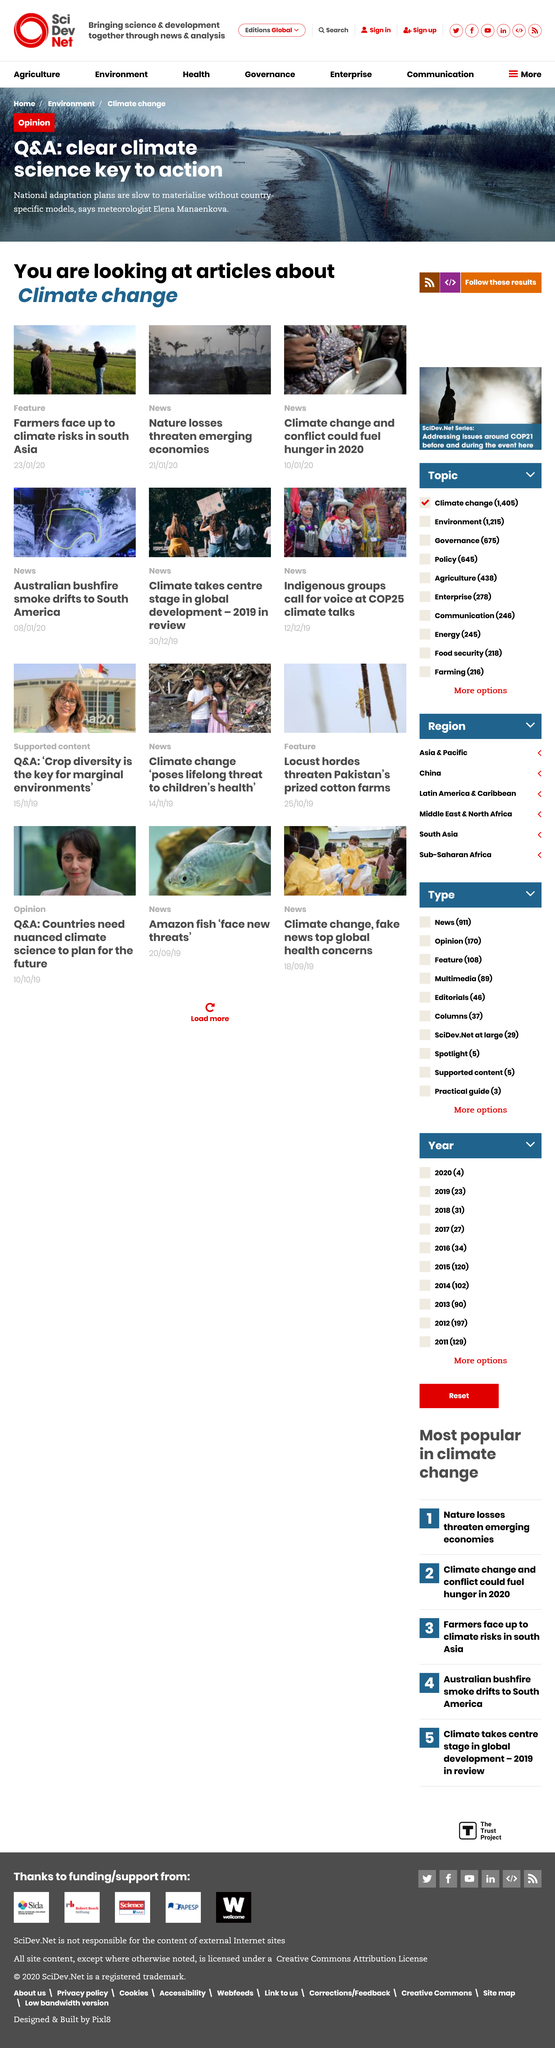Mention a couple of crucial points in this snapshot. Climate change is expected to fuel hunger in 2020 due to the potential for extreme weather events, droughts, and crop failures. The information pertains to climate change. Meteorologist Elena Manaenkova declares that plans for climate action are slow to materialize without country-specific models. 